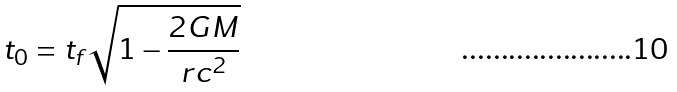<formula> <loc_0><loc_0><loc_500><loc_500>t _ { 0 } = t _ { f } \sqrt { 1 - \frac { 2 G M } { r c ^ { 2 } } }</formula> 